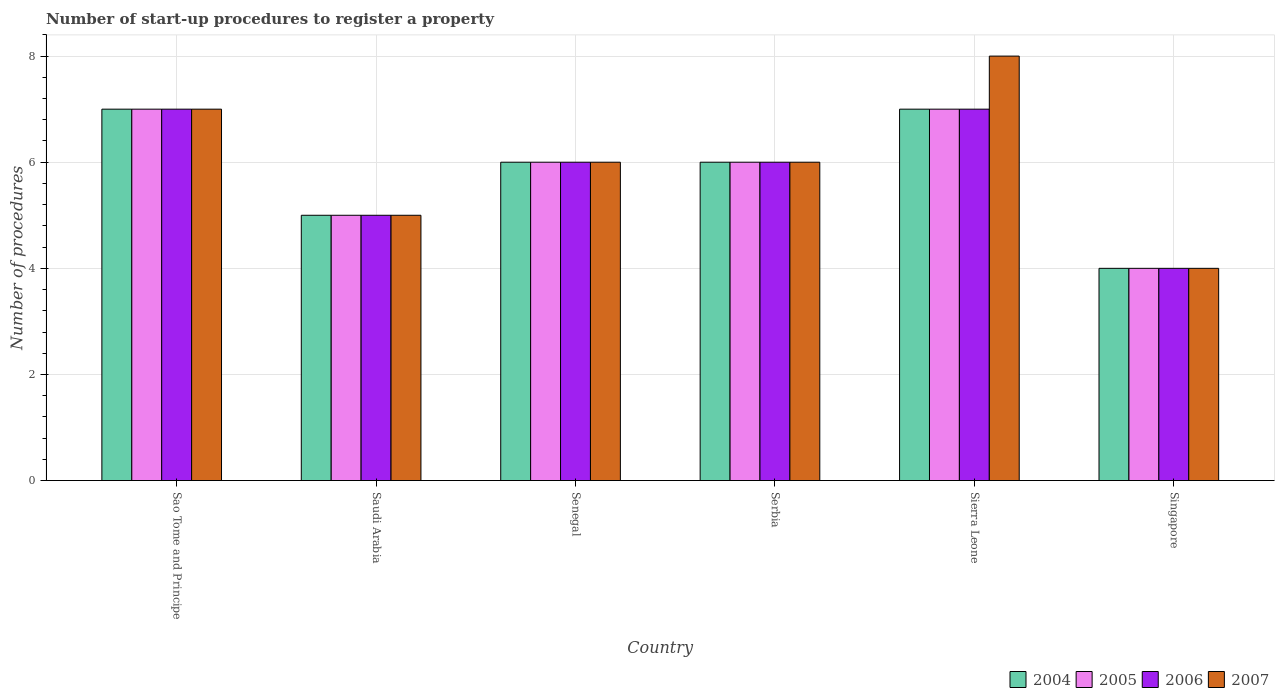How many different coloured bars are there?
Ensure brevity in your answer.  4. How many groups of bars are there?
Make the answer very short. 6. Are the number of bars per tick equal to the number of legend labels?
Give a very brief answer. Yes. How many bars are there on the 2nd tick from the left?
Offer a very short reply. 4. What is the label of the 3rd group of bars from the left?
Ensure brevity in your answer.  Senegal. In which country was the number of procedures required to register a property in 2006 maximum?
Provide a short and direct response. Sao Tome and Principe. In which country was the number of procedures required to register a property in 2007 minimum?
Your answer should be very brief. Singapore. What is the difference between the number of procedures required to register a property in 2005 in Sierra Leone and that in Singapore?
Make the answer very short. 3. What is the difference between the number of procedures required to register a property in 2007 in Sao Tome and Principe and the number of procedures required to register a property in 2005 in Senegal?
Give a very brief answer. 1. What is the average number of procedures required to register a property in 2007 per country?
Provide a succinct answer. 6. What is the ratio of the number of procedures required to register a property in 2005 in Serbia to that in Sierra Leone?
Your answer should be compact. 0.86. Is the number of procedures required to register a property in 2007 in Saudi Arabia less than that in Sierra Leone?
Offer a very short reply. Yes. What is the difference between the highest and the second highest number of procedures required to register a property in 2006?
Make the answer very short. -1. What is the difference between the highest and the lowest number of procedures required to register a property in 2006?
Offer a terse response. 3. Is it the case that in every country, the sum of the number of procedures required to register a property in 2004 and number of procedures required to register a property in 2007 is greater than the sum of number of procedures required to register a property in 2005 and number of procedures required to register a property in 2006?
Your response must be concise. No. What does the 1st bar from the left in Senegal represents?
Offer a very short reply. 2004. What does the 1st bar from the right in Sierra Leone represents?
Make the answer very short. 2007. How many bars are there?
Provide a succinct answer. 24. How many countries are there in the graph?
Your answer should be compact. 6. What is the difference between two consecutive major ticks on the Y-axis?
Make the answer very short. 2. Are the values on the major ticks of Y-axis written in scientific E-notation?
Your response must be concise. No. Does the graph contain any zero values?
Make the answer very short. No. What is the title of the graph?
Provide a short and direct response. Number of start-up procedures to register a property. What is the label or title of the X-axis?
Ensure brevity in your answer.  Country. What is the label or title of the Y-axis?
Keep it short and to the point. Number of procedures. What is the Number of procedures of 2005 in Sao Tome and Principe?
Offer a very short reply. 7. What is the Number of procedures in 2006 in Sao Tome and Principe?
Your answer should be compact. 7. What is the Number of procedures of 2006 in Saudi Arabia?
Offer a terse response. 5. What is the Number of procedures of 2007 in Saudi Arabia?
Ensure brevity in your answer.  5. What is the Number of procedures of 2004 in Senegal?
Provide a succinct answer. 6. What is the Number of procedures of 2005 in Senegal?
Provide a short and direct response. 6. What is the Number of procedures of 2007 in Senegal?
Your answer should be very brief. 6. What is the Number of procedures in 2004 in Serbia?
Make the answer very short. 6. What is the Number of procedures of 2007 in Serbia?
Offer a very short reply. 6. What is the Number of procedures in 2005 in Sierra Leone?
Provide a short and direct response. 7. What is the Number of procedures in 2007 in Sierra Leone?
Your response must be concise. 8. What is the Number of procedures of 2004 in Singapore?
Provide a short and direct response. 4. What is the Number of procedures of 2006 in Singapore?
Give a very brief answer. 4. What is the Number of procedures in 2007 in Singapore?
Your response must be concise. 4. Across all countries, what is the maximum Number of procedures of 2004?
Offer a terse response. 7. Across all countries, what is the maximum Number of procedures of 2005?
Keep it short and to the point. 7. Across all countries, what is the maximum Number of procedures of 2006?
Ensure brevity in your answer.  7. Across all countries, what is the maximum Number of procedures of 2007?
Keep it short and to the point. 8. Across all countries, what is the minimum Number of procedures of 2005?
Your answer should be very brief. 4. What is the total Number of procedures in 2005 in the graph?
Your answer should be compact. 35. What is the total Number of procedures in 2007 in the graph?
Keep it short and to the point. 36. What is the difference between the Number of procedures in 2005 in Sao Tome and Principe and that in Saudi Arabia?
Your answer should be very brief. 2. What is the difference between the Number of procedures of 2007 in Sao Tome and Principe and that in Senegal?
Ensure brevity in your answer.  1. What is the difference between the Number of procedures in 2005 in Sao Tome and Principe and that in Serbia?
Ensure brevity in your answer.  1. What is the difference between the Number of procedures of 2004 in Sao Tome and Principe and that in Sierra Leone?
Keep it short and to the point. 0. What is the difference between the Number of procedures in 2005 in Sao Tome and Principe and that in Sierra Leone?
Ensure brevity in your answer.  0. What is the difference between the Number of procedures of 2004 in Sao Tome and Principe and that in Singapore?
Your answer should be very brief. 3. What is the difference between the Number of procedures of 2006 in Sao Tome and Principe and that in Singapore?
Provide a short and direct response. 3. What is the difference between the Number of procedures in 2007 in Sao Tome and Principe and that in Singapore?
Provide a succinct answer. 3. What is the difference between the Number of procedures in 2004 in Saudi Arabia and that in Senegal?
Your answer should be very brief. -1. What is the difference between the Number of procedures in 2005 in Saudi Arabia and that in Senegal?
Your response must be concise. -1. What is the difference between the Number of procedures of 2007 in Saudi Arabia and that in Senegal?
Provide a succinct answer. -1. What is the difference between the Number of procedures of 2005 in Saudi Arabia and that in Serbia?
Your answer should be compact. -1. What is the difference between the Number of procedures in 2006 in Saudi Arabia and that in Serbia?
Ensure brevity in your answer.  -1. What is the difference between the Number of procedures in 2004 in Saudi Arabia and that in Sierra Leone?
Keep it short and to the point. -2. What is the difference between the Number of procedures of 2006 in Saudi Arabia and that in Sierra Leone?
Give a very brief answer. -2. What is the difference between the Number of procedures in 2004 in Saudi Arabia and that in Singapore?
Give a very brief answer. 1. What is the difference between the Number of procedures of 2005 in Saudi Arabia and that in Singapore?
Your answer should be very brief. 1. What is the difference between the Number of procedures of 2007 in Saudi Arabia and that in Singapore?
Your answer should be compact. 1. What is the difference between the Number of procedures of 2005 in Senegal and that in Serbia?
Your answer should be compact. 0. What is the difference between the Number of procedures in 2007 in Senegal and that in Serbia?
Keep it short and to the point. 0. What is the difference between the Number of procedures in 2004 in Senegal and that in Sierra Leone?
Offer a very short reply. -1. What is the difference between the Number of procedures in 2007 in Senegal and that in Sierra Leone?
Give a very brief answer. -2. What is the difference between the Number of procedures in 2004 in Senegal and that in Singapore?
Give a very brief answer. 2. What is the difference between the Number of procedures of 2007 in Senegal and that in Singapore?
Your answer should be compact. 2. What is the difference between the Number of procedures in 2004 in Serbia and that in Sierra Leone?
Provide a succinct answer. -1. What is the difference between the Number of procedures of 2005 in Serbia and that in Sierra Leone?
Your response must be concise. -1. What is the difference between the Number of procedures in 2005 in Serbia and that in Singapore?
Provide a succinct answer. 2. What is the difference between the Number of procedures in 2005 in Sierra Leone and that in Singapore?
Make the answer very short. 3. What is the difference between the Number of procedures of 2007 in Sierra Leone and that in Singapore?
Offer a very short reply. 4. What is the difference between the Number of procedures of 2004 in Sao Tome and Principe and the Number of procedures of 2005 in Saudi Arabia?
Provide a short and direct response. 2. What is the difference between the Number of procedures of 2004 in Sao Tome and Principe and the Number of procedures of 2007 in Saudi Arabia?
Give a very brief answer. 2. What is the difference between the Number of procedures in 2005 in Sao Tome and Principe and the Number of procedures in 2006 in Saudi Arabia?
Make the answer very short. 2. What is the difference between the Number of procedures in 2004 in Sao Tome and Principe and the Number of procedures in 2005 in Senegal?
Ensure brevity in your answer.  1. What is the difference between the Number of procedures of 2004 in Sao Tome and Principe and the Number of procedures of 2006 in Senegal?
Give a very brief answer. 1. What is the difference between the Number of procedures of 2005 in Sao Tome and Principe and the Number of procedures of 2007 in Senegal?
Give a very brief answer. 1. What is the difference between the Number of procedures of 2006 in Sao Tome and Principe and the Number of procedures of 2007 in Senegal?
Give a very brief answer. 1. What is the difference between the Number of procedures in 2005 in Sao Tome and Principe and the Number of procedures in 2006 in Serbia?
Make the answer very short. 1. What is the difference between the Number of procedures in 2006 in Sao Tome and Principe and the Number of procedures in 2007 in Serbia?
Give a very brief answer. 1. What is the difference between the Number of procedures in 2004 in Sao Tome and Principe and the Number of procedures in 2005 in Sierra Leone?
Keep it short and to the point. 0. What is the difference between the Number of procedures in 2005 in Sao Tome and Principe and the Number of procedures in 2006 in Sierra Leone?
Provide a short and direct response. 0. What is the difference between the Number of procedures of 2005 in Sao Tome and Principe and the Number of procedures of 2007 in Sierra Leone?
Provide a short and direct response. -1. What is the difference between the Number of procedures of 2006 in Sao Tome and Principe and the Number of procedures of 2007 in Sierra Leone?
Make the answer very short. -1. What is the difference between the Number of procedures in 2004 in Sao Tome and Principe and the Number of procedures in 2005 in Singapore?
Your answer should be very brief. 3. What is the difference between the Number of procedures in 2004 in Sao Tome and Principe and the Number of procedures in 2007 in Singapore?
Your answer should be compact. 3. What is the difference between the Number of procedures of 2005 in Sao Tome and Principe and the Number of procedures of 2006 in Singapore?
Your answer should be compact. 3. What is the difference between the Number of procedures in 2004 in Saudi Arabia and the Number of procedures in 2005 in Senegal?
Give a very brief answer. -1. What is the difference between the Number of procedures of 2004 in Saudi Arabia and the Number of procedures of 2006 in Senegal?
Keep it short and to the point. -1. What is the difference between the Number of procedures in 2004 in Saudi Arabia and the Number of procedures in 2007 in Senegal?
Ensure brevity in your answer.  -1. What is the difference between the Number of procedures in 2005 in Saudi Arabia and the Number of procedures in 2006 in Senegal?
Give a very brief answer. -1. What is the difference between the Number of procedures of 2005 in Saudi Arabia and the Number of procedures of 2007 in Senegal?
Your response must be concise. -1. What is the difference between the Number of procedures in 2006 in Saudi Arabia and the Number of procedures in 2007 in Senegal?
Offer a very short reply. -1. What is the difference between the Number of procedures of 2004 in Saudi Arabia and the Number of procedures of 2005 in Serbia?
Ensure brevity in your answer.  -1. What is the difference between the Number of procedures of 2004 in Saudi Arabia and the Number of procedures of 2007 in Serbia?
Provide a succinct answer. -1. What is the difference between the Number of procedures in 2005 in Saudi Arabia and the Number of procedures in 2006 in Serbia?
Your response must be concise. -1. What is the difference between the Number of procedures in 2005 in Saudi Arabia and the Number of procedures in 2007 in Serbia?
Offer a very short reply. -1. What is the difference between the Number of procedures of 2006 in Saudi Arabia and the Number of procedures of 2007 in Serbia?
Your response must be concise. -1. What is the difference between the Number of procedures of 2004 in Saudi Arabia and the Number of procedures of 2007 in Sierra Leone?
Keep it short and to the point. -3. What is the difference between the Number of procedures in 2005 in Saudi Arabia and the Number of procedures in 2006 in Sierra Leone?
Ensure brevity in your answer.  -2. What is the difference between the Number of procedures of 2006 in Saudi Arabia and the Number of procedures of 2007 in Sierra Leone?
Keep it short and to the point. -3. What is the difference between the Number of procedures of 2005 in Saudi Arabia and the Number of procedures of 2007 in Singapore?
Your response must be concise. 1. What is the difference between the Number of procedures in 2004 in Senegal and the Number of procedures in 2005 in Serbia?
Your answer should be very brief. 0. What is the difference between the Number of procedures of 2005 in Senegal and the Number of procedures of 2006 in Serbia?
Your response must be concise. 0. What is the difference between the Number of procedures of 2004 in Senegal and the Number of procedures of 2007 in Sierra Leone?
Give a very brief answer. -2. What is the difference between the Number of procedures in 2006 in Senegal and the Number of procedures in 2007 in Sierra Leone?
Give a very brief answer. -2. What is the difference between the Number of procedures in 2004 in Senegal and the Number of procedures in 2005 in Singapore?
Offer a very short reply. 2. What is the difference between the Number of procedures of 2004 in Senegal and the Number of procedures of 2007 in Singapore?
Give a very brief answer. 2. What is the difference between the Number of procedures in 2006 in Senegal and the Number of procedures in 2007 in Singapore?
Your answer should be very brief. 2. What is the difference between the Number of procedures of 2004 in Serbia and the Number of procedures of 2006 in Sierra Leone?
Offer a very short reply. -1. What is the difference between the Number of procedures in 2004 in Serbia and the Number of procedures in 2007 in Sierra Leone?
Offer a terse response. -2. What is the difference between the Number of procedures in 2005 in Serbia and the Number of procedures in 2006 in Sierra Leone?
Give a very brief answer. -1. What is the difference between the Number of procedures of 2005 in Serbia and the Number of procedures of 2007 in Sierra Leone?
Provide a short and direct response. -2. What is the difference between the Number of procedures in 2004 in Serbia and the Number of procedures in 2005 in Singapore?
Provide a succinct answer. 2. What is the difference between the Number of procedures in 2004 in Serbia and the Number of procedures in 2006 in Singapore?
Provide a short and direct response. 2. What is the difference between the Number of procedures in 2004 in Serbia and the Number of procedures in 2007 in Singapore?
Give a very brief answer. 2. What is the difference between the Number of procedures of 2005 in Serbia and the Number of procedures of 2006 in Singapore?
Your answer should be very brief. 2. What is the difference between the Number of procedures of 2006 in Serbia and the Number of procedures of 2007 in Singapore?
Offer a terse response. 2. What is the difference between the Number of procedures of 2004 in Sierra Leone and the Number of procedures of 2006 in Singapore?
Your response must be concise. 3. What is the difference between the Number of procedures in 2004 in Sierra Leone and the Number of procedures in 2007 in Singapore?
Provide a succinct answer. 3. What is the average Number of procedures in 2004 per country?
Provide a succinct answer. 5.83. What is the average Number of procedures in 2005 per country?
Your answer should be very brief. 5.83. What is the average Number of procedures in 2006 per country?
Offer a very short reply. 5.83. What is the average Number of procedures in 2007 per country?
Your answer should be very brief. 6. What is the difference between the Number of procedures of 2004 and Number of procedures of 2005 in Sao Tome and Principe?
Make the answer very short. 0. What is the difference between the Number of procedures of 2004 and Number of procedures of 2006 in Sao Tome and Principe?
Ensure brevity in your answer.  0. What is the difference between the Number of procedures of 2005 and Number of procedures of 2006 in Sao Tome and Principe?
Provide a succinct answer. 0. What is the difference between the Number of procedures of 2005 and Number of procedures of 2007 in Sao Tome and Principe?
Your response must be concise. 0. What is the difference between the Number of procedures in 2006 and Number of procedures in 2007 in Sao Tome and Principe?
Offer a very short reply. 0. What is the difference between the Number of procedures in 2004 and Number of procedures in 2007 in Saudi Arabia?
Your response must be concise. 0. What is the difference between the Number of procedures in 2005 and Number of procedures in 2006 in Saudi Arabia?
Provide a short and direct response. 0. What is the difference between the Number of procedures in 2005 and Number of procedures in 2007 in Saudi Arabia?
Your response must be concise. 0. What is the difference between the Number of procedures of 2006 and Number of procedures of 2007 in Saudi Arabia?
Ensure brevity in your answer.  0. What is the difference between the Number of procedures in 2004 and Number of procedures in 2007 in Senegal?
Offer a very short reply. 0. What is the difference between the Number of procedures in 2005 and Number of procedures in 2007 in Senegal?
Your response must be concise. 0. What is the difference between the Number of procedures in 2006 and Number of procedures in 2007 in Senegal?
Make the answer very short. 0. What is the difference between the Number of procedures in 2004 and Number of procedures in 2006 in Serbia?
Make the answer very short. 0. What is the difference between the Number of procedures in 2004 and Number of procedures in 2007 in Serbia?
Ensure brevity in your answer.  0. What is the difference between the Number of procedures in 2005 and Number of procedures in 2007 in Serbia?
Provide a succinct answer. 0. What is the difference between the Number of procedures in 2006 and Number of procedures in 2007 in Serbia?
Make the answer very short. 0. What is the difference between the Number of procedures of 2004 and Number of procedures of 2005 in Sierra Leone?
Provide a succinct answer. 0. What is the difference between the Number of procedures in 2004 and Number of procedures in 2006 in Sierra Leone?
Offer a very short reply. 0. What is the difference between the Number of procedures of 2004 and Number of procedures of 2007 in Sierra Leone?
Your answer should be compact. -1. What is the difference between the Number of procedures of 2005 and Number of procedures of 2006 in Sierra Leone?
Make the answer very short. 0. What is the difference between the Number of procedures of 2005 and Number of procedures of 2007 in Sierra Leone?
Make the answer very short. -1. What is the difference between the Number of procedures in 2004 and Number of procedures in 2005 in Singapore?
Your response must be concise. 0. What is the difference between the Number of procedures in 2004 and Number of procedures in 2006 in Singapore?
Ensure brevity in your answer.  0. What is the difference between the Number of procedures in 2005 and Number of procedures in 2006 in Singapore?
Offer a terse response. 0. What is the difference between the Number of procedures of 2006 and Number of procedures of 2007 in Singapore?
Give a very brief answer. 0. What is the ratio of the Number of procedures in 2005 in Sao Tome and Principe to that in Saudi Arabia?
Offer a terse response. 1.4. What is the ratio of the Number of procedures in 2006 in Sao Tome and Principe to that in Saudi Arabia?
Your answer should be compact. 1.4. What is the ratio of the Number of procedures in 2007 in Sao Tome and Principe to that in Saudi Arabia?
Provide a short and direct response. 1.4. What is the ratio of the Number of procedures in 2007 in Sao Tome and Principe to that in Senegal?
Give a very brief answer. 1.17. What is the ratio of the Number of procedures in 2004 in Sao Tome and Principe to that in Serbia?
Provide a succinct answer. 1.17. What is the ratio of the Number of procedures in 2005 in Sao Tome and Principe to that in Serbia?
Make the answer very short. 1.17. What is the ratio of the Number of procedures in 2006 in Sao Tome and Principe to that in Serbia?
Keep it short and to the point. 1.17. What is the ratio of the Number of procedures of 2004 in Sao Tome and Principe to that in Sierra Leone?
Ensure brevity in your answer.  1. What is the ratio of the Number of procedures in 2005 in Sao Tome and Principe to that in Singapore?
Give a very brief answer. 1.75. What is the ratio of the Number of procedures of 2007 in Sao Tome and Principe to that in Singapore?
Provide a short and direct response. 1.75. What is the ratio of the Number of procedures in 2004 in Saudi Arabia to that in Senegal?
Your answer should be compact. 0.83. What is the ratio of the Number of procedures of 2005 in Saudi Arabia to that in Serbia?
Your response must be concise. 0.83. What is the ratio of the Number of procedures of 2007 in Saudi Arabia to that in Serbia?
Provide a short and direct response. 0.83. What is the ratio of the Number of procedures of 2006 in Saudi Arabia to that in Sierra Leone?
Ensure brevity in your answer.  0.71. What is the ratio of the Number of procedures in 2004 in Saudi Arabia to that in Singapore?
Offer a very short reply. 1.25. What is the ratio of the Number of procedures of 2006 in Saudi Arabia to that in Singapore?
Make the answer very short. 1.25. What is the ratio of the Number of procedures in 2005 in Senegal to that in Serbia?
Your answer should be very brief. 1. What is the ratio of the Number of procedures in 2006 in Senegal to that in Serbia?
Your response must be concise. 1. What is the ratio of the Number of procedures in 2005 in Senegal to that in Sierra Leone?
Your answer should be very brief. 0.86. What is the ratio of the Number of procedures of 2007 in Senegal to that in Sierra Leone?
Offer a terse response. 0.75. What is the ratio of the Number of procedures of 2004 in Senegal to that in Singapore?
Your answer should be compact. 1.5. What is the ratio of the Number of procedures in 2005 in Senegal to that in Singapore?
Provide a succinct answer. 1.5. What is the ratio of the Number of procedures of 2006 in Senegal to that in Singapore?
Your response must be concise. 1.5. What is the ratio of the Number of procedures of 2004 in Serbia to that in Sierra Leone?
Provide a succinct answer. 0.86. What is the ratio of the Number of procedures of 2006 in Serbia to that in Sierra Leone?
Make the answer very short. 0.86. What is the ratio of the Number of procedures of 2007 in Serbia to that in Sierra Leone?
Keep it short and to the point. 0.75. What is the ratio of the Number of procedures of 2004 in Serbia to that in Singapore?
Keep it short and to the point. 1.5. What is the ratio of the Number of procedures of 2005 in Serbia to that in Singapore?
Offer a terse response. 1.5. What is the ratio of the Number of procedures of 2006 in Serbia to that in Singapore?
Offer a terse response. 1.5. What is the ratio of the Number of procedures in 2007 in Serbia to that in Singapore?
Give a very brief answer. 1.5. What is the ratio of the Number of procedures in 2004 in Sierra Leone to that in Singapore?
Provide a succinct answer. 1.75. What is the ratio of the Number of procedures in 2005 in Sierra Leone to that in Singapore?
Give a very brief answer. 1.75. What is the ratio of the Number of procedures in 2007 in Sierra Leone to that in Singapore?
Keep it short and to the point. 2. What is the difference between the highest and the second highest Number of procedures of 2004?
Your answer should be very brief. 0. What is the difference between the highest and the second highest Number of procedures in 2005?
Offer a terse response. 0. What is the difference between the highest and the second highest Number of procedures of 2006?
Offer a very short reply. 0. What is the difference between the highest and the lowest Number of procedures in 2005?
Your response must be concise. 3. What is the difference between the highest and the lowest Number of procedures of 2006?
Offer a very short reply. 3. 